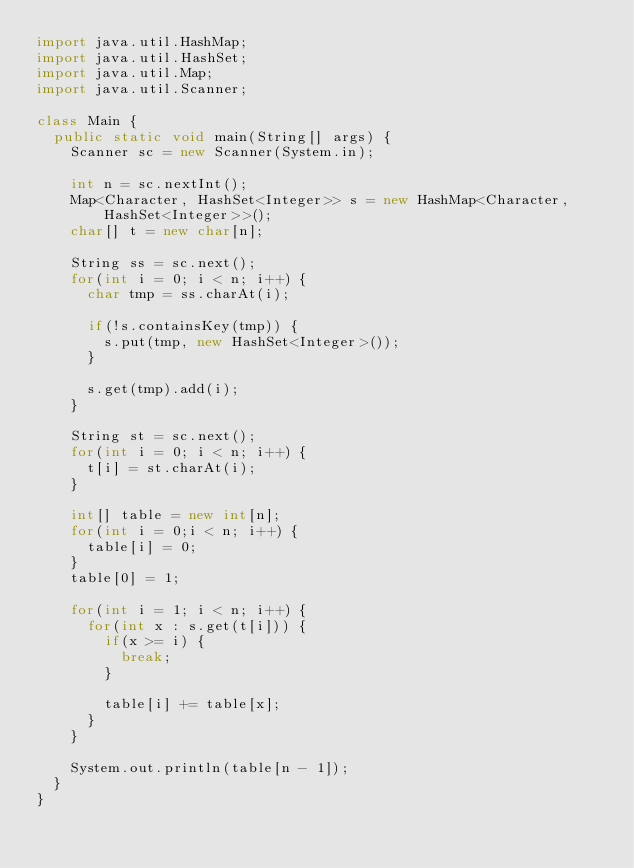Convert code to text. <code><loc_0><loc_0><loc_500><loc_500><_Java_>import java.util.HashMap;
import java.util.HashSet;
import java.util.Map;
import java.util.Scanner;

class Main {
	public static void main(String[] args) {
		Scanner sc = new Scanner(System.in);
		
		int n = sc.nextInt();
		Map<Character, HashSet<Integer>> s = new HashMap<Character, HashSet<Integer>>();
		char[] t = new char[n];
		
		String ss = sc.next();
		for(int i = 0; i < n; i++) {
			char tmp = ss.charAt(i);
			
			if(!s.containsKey(tmp)) {
				s.put(tmp, new HashSet<Integer>());
			}
			
			s.get(tmp).add(i);
		}
		
		String st = sc.next();
		for(int i = 0; i < n; i++) {
			t[i] = st.charAt(i);
		}
		
		int[] table = new int[n];
		for(int i = 0;i < n; i++) {
			table[i] = 0;
		}
		table[0] = 1;
		
		for(int i = 1; i < n; i++) {
			for(int x : s.get(t[i])) {
				if(x >= i) {
					break;
				}
				
				table[i] += table[x];
			}
		}
		
		System.out.println(table[n - 1]);
	}
}
</code> 